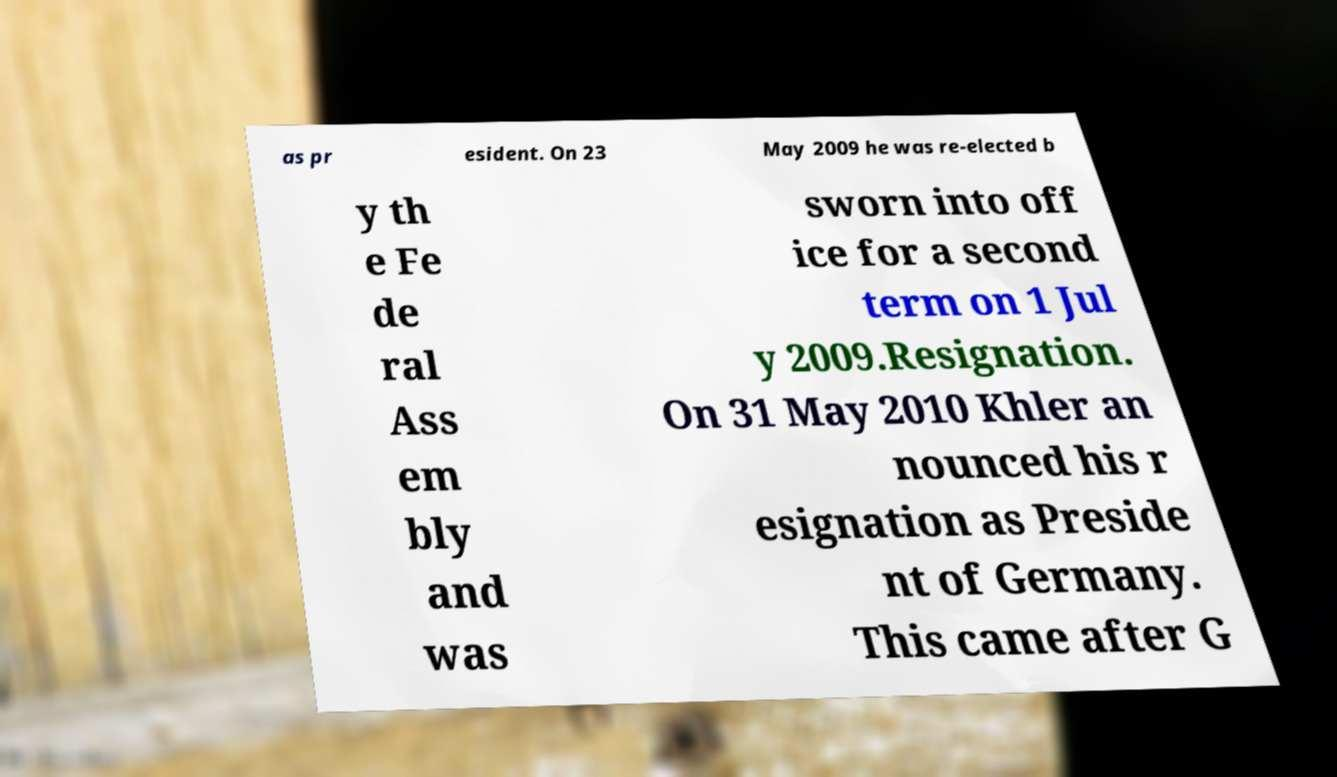What messages or text are displayed in this image? I need them in a readable, typed format. as pr esident. On 23 May 2009 he was re-elected b y th e Fe de ral Ass em bly and was sworn into off ice for a second term on 1 Jul y 2009.Resignation. On 31 May 2010 Khler an nounced his r esignation as Preside nt of Germany. This came after G 